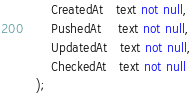<code> <loc_0><loc_0><loc_500><loc_500><_SQL_>    CreatedAt   text not null,
    PushedAt    text not null,
    UpdatedAt   text not null,
    CheckedAt   text not null
);
</code> 